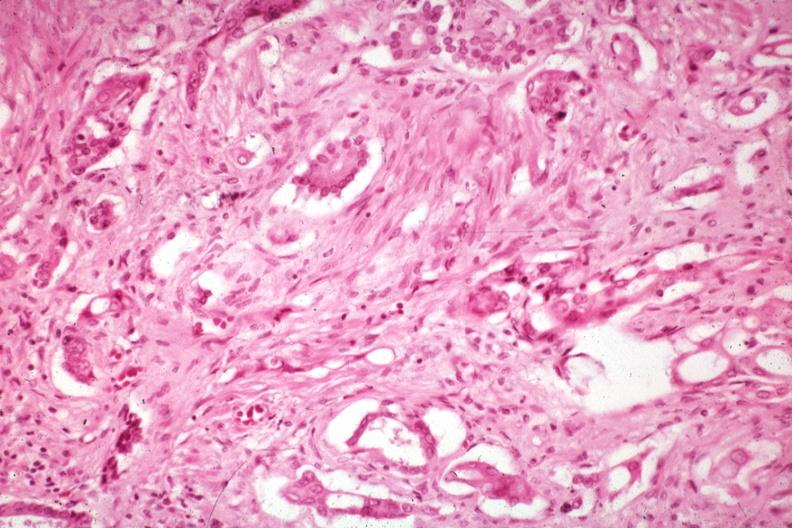what does this image show?
Answer the question using a single word or phrase. Anaplastic carcinoma with desmoplasia large myofibroblastic cell are prominent in the stroma 